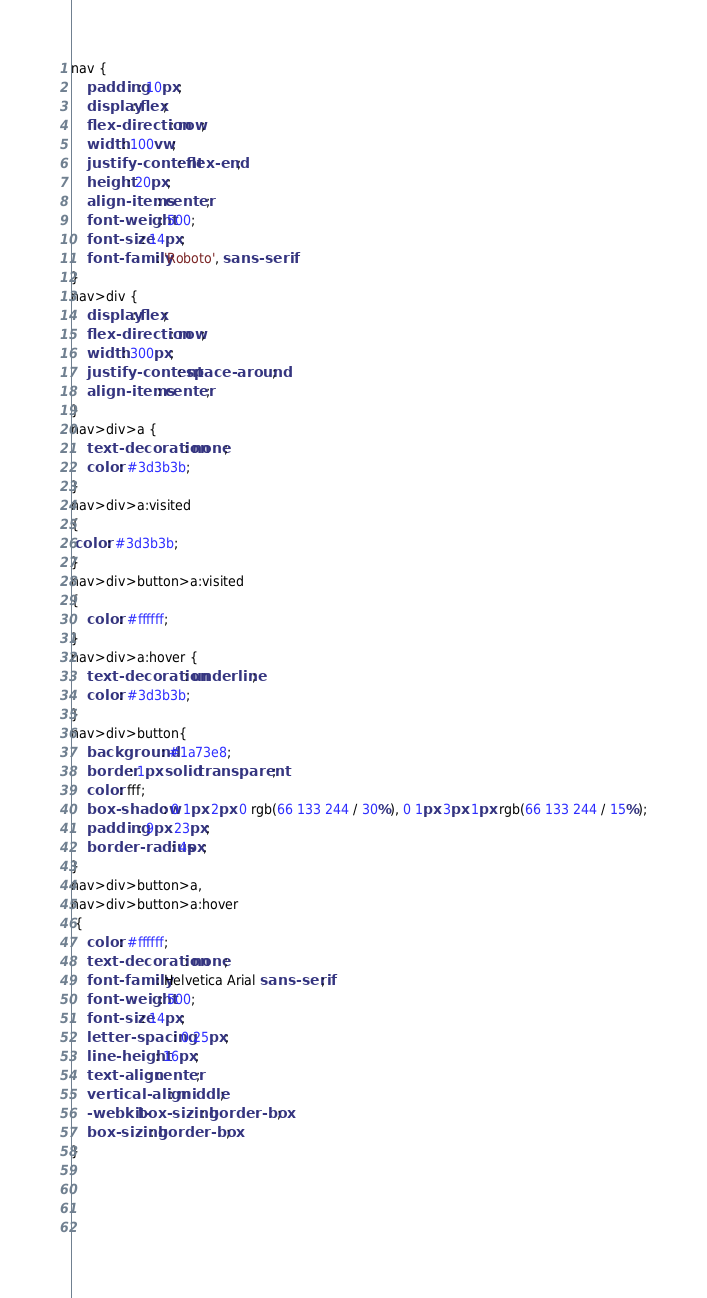<code> <loc_0><loc_0><loc_500><loc_500><_CSS_>nav {
    padding: 10px;
    display: flex;
    flex-direction: row;
    width: 100vw;
    justify-content: flex-end;
    height: 20px;
    align-items: center;
    font-weight: 500;
    font-size: 14px;
    font-family: 'Roboto', sans-serif
}
nav>div {
    display: flex;
    flex-direction: row;
    width: 300px;
    justify-content: space-around;
    align-items: center;
}
nav>div>a {
    text-decoration: none;
    color: #3d3b3b;
}
nav>div>a:visited
{
 color: #3d3b3b;  
}
nav>div>button>a:visited
{
    color: #ffffff;
}
nav>div>a:hover {
    text-decoration: underline;
    color: #3d3b3b;
}
nav>div>button{
    background: #1a73e8;
    border: 1px solid transparent;
    color: fff;
    box-shadow: 0 1px 2px 0 rgb(66 133 244 / 30%), 0 1px 3px 1px rgb(66 133 244 / 15%);
    padding: 9px 23px;
    border-radius: 4px;
}
nav>div>button>a, 
nav>div>button>a:hover
 {
    color: #ffffff;
    text-decoration: none;
    font-family: Helvetica Arial sans-serif;
    font-weight: 500;
    font-size: 14px;
    letter-spacing: 0.25px;
    line-height: 16px;
    text-align: center;
    vertical-align: middle;
    -webkit-box-sizing: border-box;
    box-sizing: border-box;
}



    
</code> 